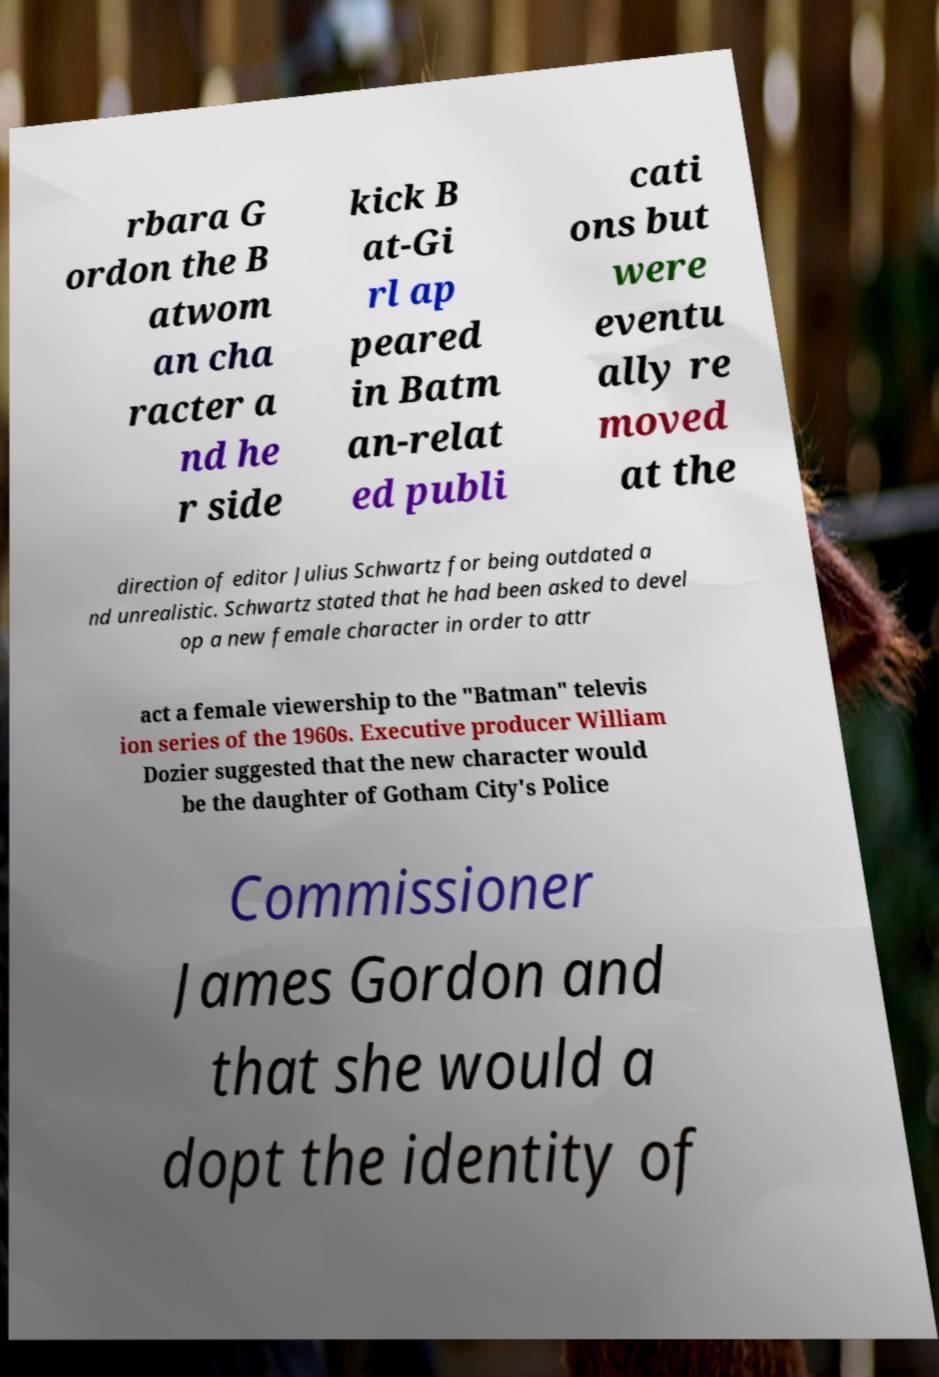Please identify and transcribe the text found in this image. rbara G ordon the B atwom an cha racter a nd he r side kick B at-Gi rl ap peared in Batm an-relat ed publi cati ons but were eventu ally re moved at the direction of editor Julius Schwartz for being outdated a nd unrealistic. Schwartz stated that he had been asked to devel op a new female character in order to attr act a female viewership to the "Batman" televis ion series of the 1960s. Executive producer William Dozier suggested that the new character would be the daughter of Gotham City's Police Commissioner James Gordon and that she would a dopt the identity of 